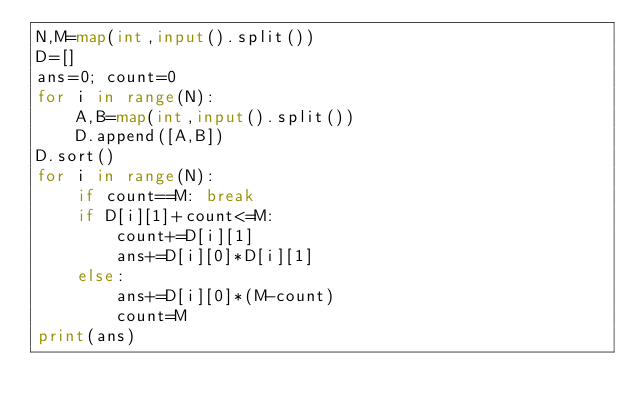<code> <loc_0><loc_0><loc_500><loc_500><_Python_>N,M=map(int,input().split())
D=[]
ans=0; count=0
for i in range(N): 
    A,B=map(int,input().split())
    D.append([A,B])
D.sort()
for i in range(N):
    if count==M: break
    if D[i][1]+count<=M:
        count+=D[i][1]
        ans+=D[i][0]*D[i][1]
    else:
        ans+=D[i][0]*(M-count)
        count=M
print(ans)</code> 